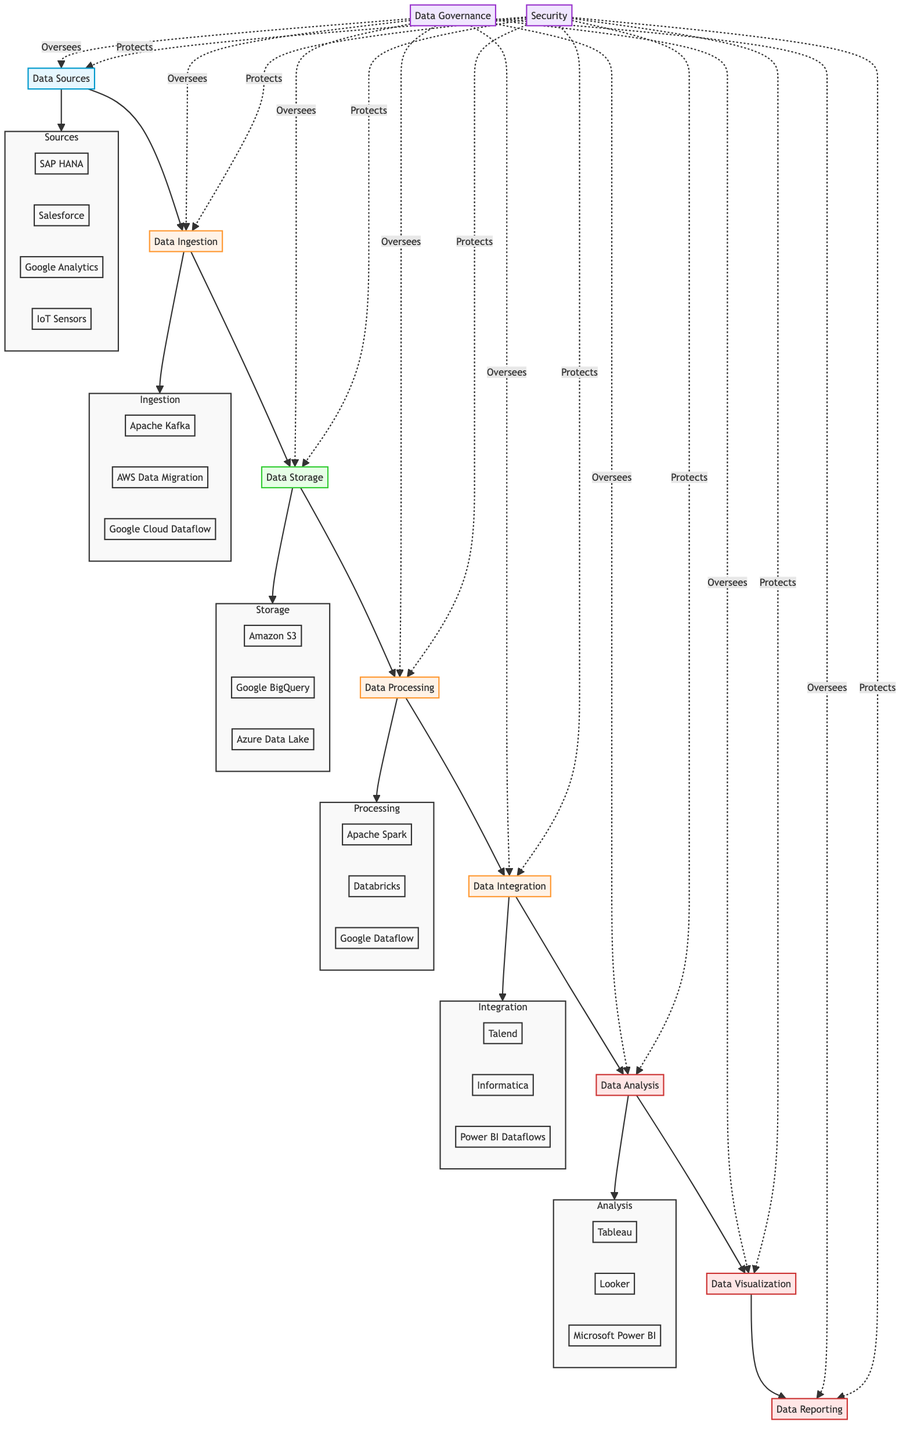What are the components of Data Storage? The "Data Storage" node lists three components: Amazon S3, Google BigQuery, and Azure Data Lake Storage.
Answer: Amazon S3, Google BigQuery, Azure Data Lake Storage How many data sources are represented? The diagram illustrates four data sources: SAP HANA, Salesforce, Google Analytics, and IoT Sensors, which are connected to the "Data Sources" node.
Answer: Four Which nodes are linked to the Data Processing node? The Data Processing node is connected to the Data Storage node (input) and the Data Integration node (output), creating a directional flow through the pipeline.
Answer: Data Storage, Data Integration What is the purpose of the Data Governance node? The Data Governance node specifies that it oversees all stages of the pipeline, ensuring data quality and compliance within the entire flow represented in the diagram.
Answer: Oversees all stages List the data analysis tools mentioned in the diagram. The "Data Analysis" node identifies three tools: Tableau, Looker, and Microsoft Power BI, which help analyze the integrated data for insights.
Answer: Tableau, Looker, Microsoft Power BI How does Security relate to the data pipeline? The Security node indicates safeguards for all stages of the data pipeline, protecting inputs and outputs at every point indicated in the diagram.
Answer: Protects all stages What is the last step in the data pipeline? The last step depicted in the diagram is the Data Reporting node, which generates business reports based on analyzed data from the previous processes.
Answer: Data Reporting Which component is involved in Data Ingestion? The Data Ingestion node mentions three components: Apache Kafka, AWS Data Migration Service, and Google Cloud Dataflow, responsible for gathering data from various sources.
Answer: Apache Kafka, AWS Data Migration Service, Google Cloud Dataflow What signifies the flow between Data Integration and Data Analysis? The diagram shows an arrow connecting Data Integration to Data Analysis, indicating a direct flow of data transformation into actionable insights through analysis.
Answer: Direct flow of data 